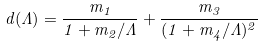Convert formula to latex. <formula><loc_0><loc_0><loc_500><loc_500>d ( \Lambda ) = \frac { m _ { 1 } } { 1 + m _ { 2 } / \Lambda } + \frac { m _ { 3 } } { ( 1 + m _ { 4 } / \Lambda ) ^ { 2 } }</formula> 